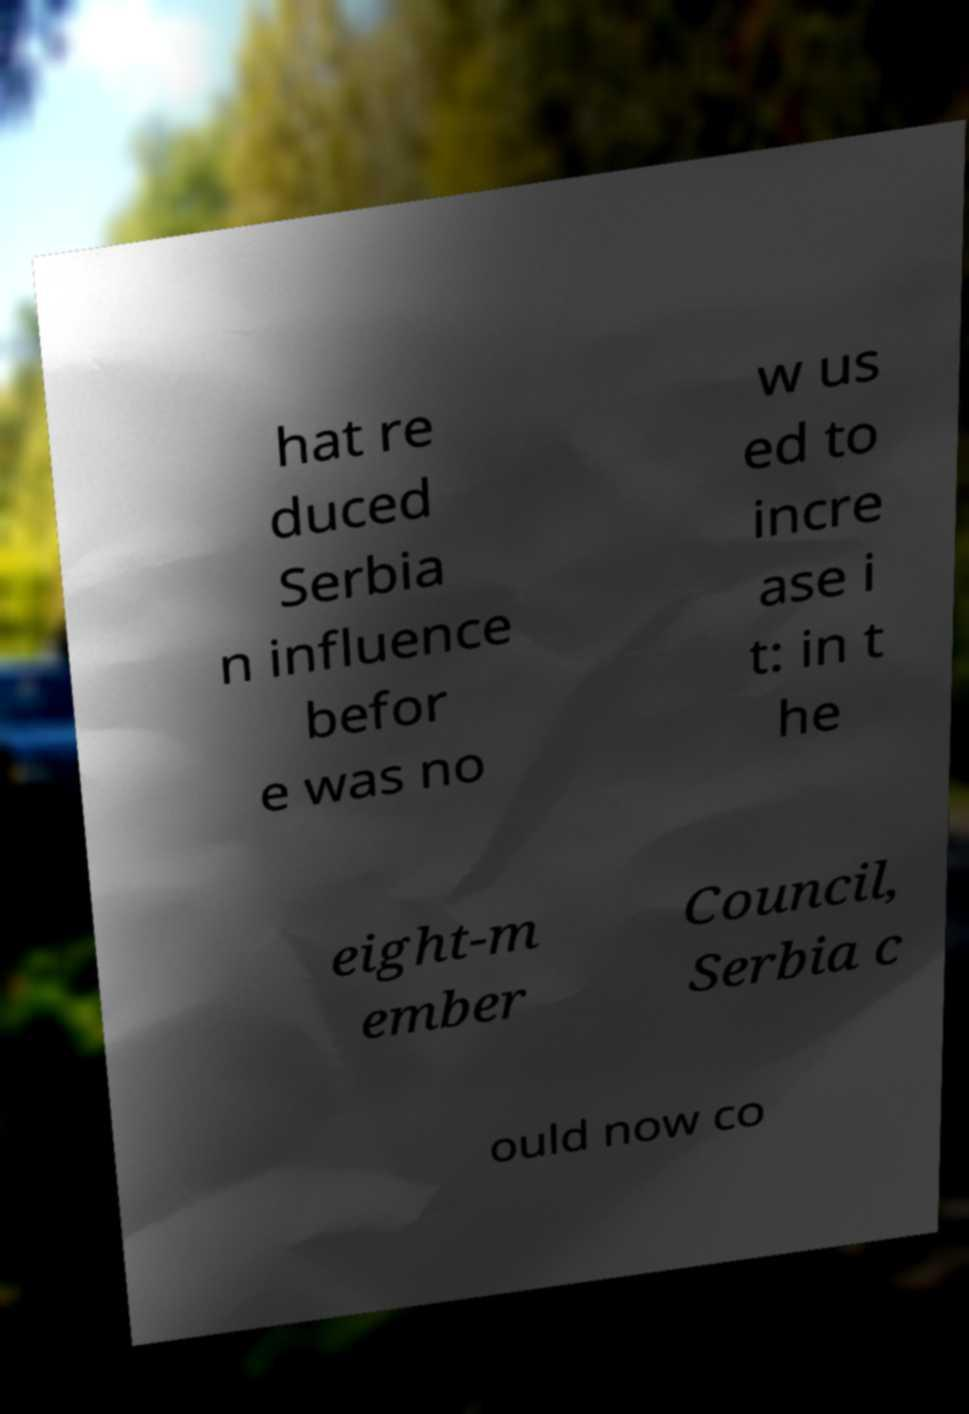For documentation purposes, I need the text within this image transcribed. Could you provide that? hat re duced Serbia n influence befor e was no w us ed to incre ase i t: in t he eight-m ember Council, Serbia c ould now co 